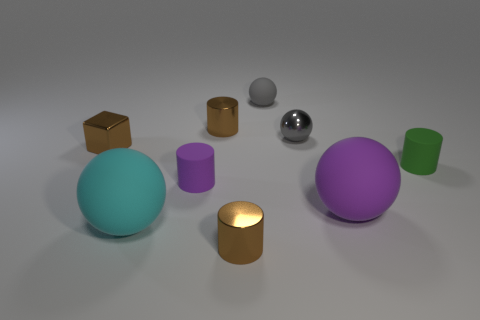How many rubber cylinders are on the left side of the small gray matte thing?
Offer a terse response. 1. Are there any things of the same color as the cube?
Offer a terse response. Yes. What is the shape of the gray thing that is the same size as the gray rubber sphere?
Offer a very short reply. Sphere. What number of green objects are small rubber objects or cubes?
Make the answer very short. 1. What number of brown metallic cylinders are the same size as the gray shiny thing?
Keep it short and to the point. 2. The tiny thing that is the same color as the small shiny ball is what shape?
Give a very brief answer. Sphere. How many objects are cyan things or tiny brown objects that are in front of the small brown cube?
Ensure brevity in your answer.  2. Do the brown cylinder that is in front of the cyan rubber thing and the purple object that is to the right of the tiny purple cylinder have the same size?
Your answer should be compact. No. What number of other metallic objects are the same shape as the green thing?
Offer a terse response. 2. The tiny green object that is the same material as the cyan thing is what shape?
Your answer should be compact. Cylinder. 